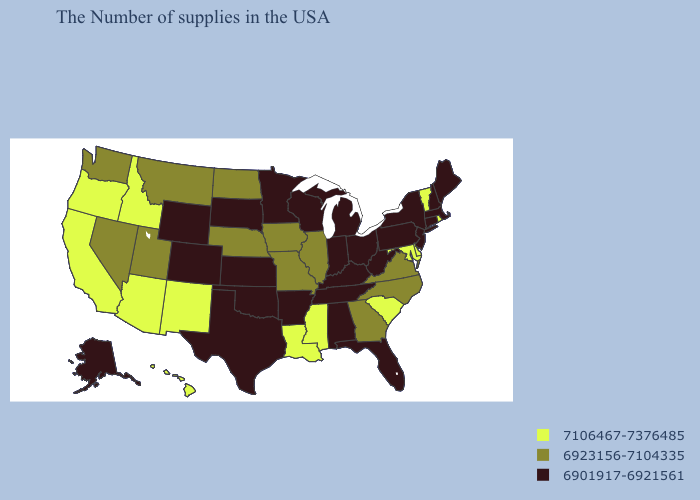Does Alaska have the same value as New Hampshire?
Give a very brief answer. Yes. What is the highest value in states that border Texas?
Short answer required. 7106467-7376485. What is the lowest value in the MidWest?
Quick response, please. 6901917-6921561. Does Rhode Island have a lower value than Ohio?
Concise answer only. No. Does Vermont have the highest value in the Northeast?
Answer briefly. Yes. Among the states that border New Hampshire , does Vermont have the highest value?
Write a very short answer. Yes. Does the first symbol in the legend represent the smallest category?
Short answer required. No. Name the states that have a value in the range 6901917-6921561?
Concise answer only. Maine, Massachusetts, New Hampshire, Connecticut, New York, New Jersey, Pennsylvania, West Virginia, Ohio, Florida, Michigan, Kentucky, Indiana, Alabama, Tennessee, Wisconsin, Arkansas, Minnesota, Kansas, Oklahoma, Texas, South Dakota, Wyoming, Colorado, Alaska. Does the map have missing data?
Answer briefly. No. Name the states that have a value in the range 7106467-7376485?
Write a very short answer. Rhode Island, Vermont, Delaware, Maryland, South Carolina, Mississippi, Louisiana, New Mexico, Arizona, Idaho, California, Oregon, Hawaii. What is the value of Maine?
Write a very short answer. 6901917-6921561. What is the highest value in the USA?
Keep it brief. 7106467-7376485. Name the states that have a value in the range 7106467-7376485?
Write a very short answer. Rhode Island, Vermont, Delaware, Maryland, South Carolina, Mississippi, Louisiana, New Mexico, Arizona, Idaho, California, Oregon, Hawaii. Does the first symbol in the legend represent the smallest category?
Answer briefly. No. Name the states that have a value in the range 6901917-6921561?
Keep it brief. Maine, Massachusetts, New Hampshire, Connecticut, New York, New Jersey, Pennsylvania, West Virginia, Ohio, Florida, Michigan, Kentucky, Indiana, Alabama, Tennessee, Wisconsin, Arkansas, Minnesota, Kansas, Oklahoma, Texas, South Dakota, Wyoming, Colorado, Alaska. 